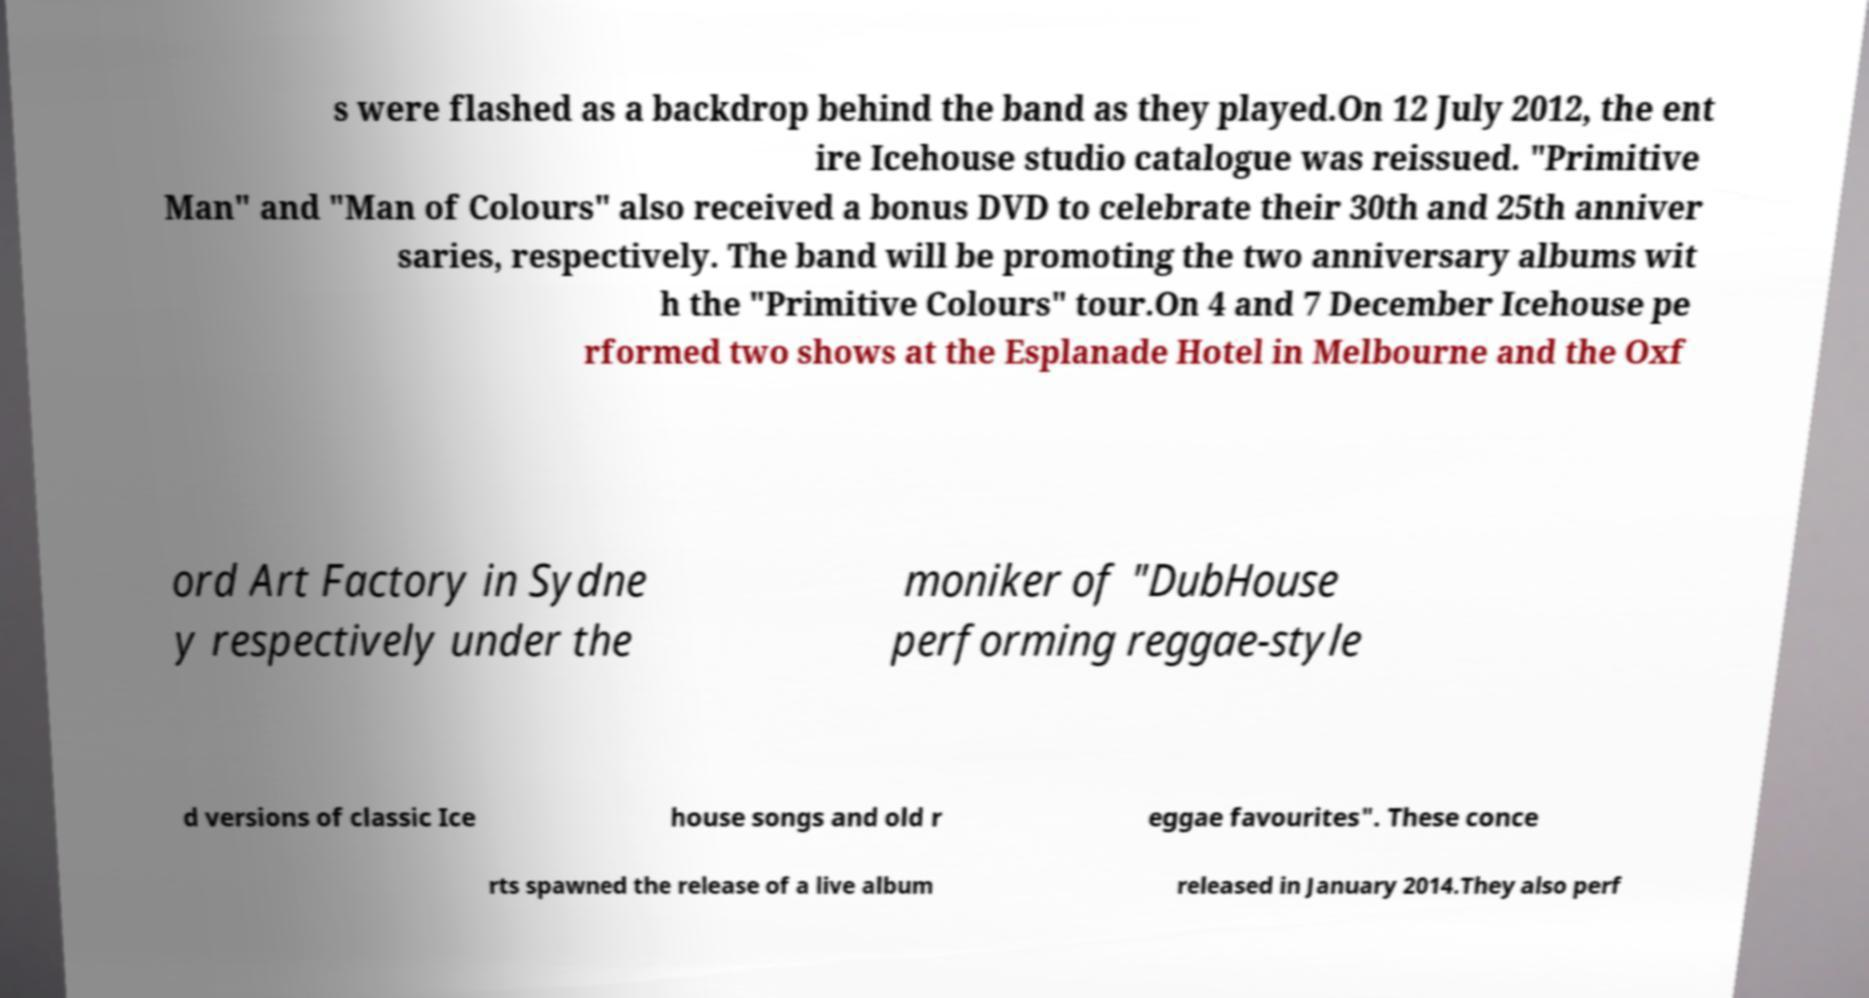What messages or text are displayed in this image? I need them in a readable, typed format. s were flashed as a backdrop behind the band as they played.On 12 July 2012, the ent ire Icehouse studio catalogue was reissued. "Primitive Man" and "Man of Colours" also received a bonus DVD to celebrate their 30th and 25th anniver saries, respectively. The band will be promoting the two anniversary albums wit h the "Primitive Colours" tour.On 4 and 7 December Icehouse pe rformed two shows at the Esplanade Hotel in Melbourne and the Oxf ord Art Factory in Sydne y respectively under the moniker of "DubHouse performing reggae-style d versions of classic Ice house songs and old r eggae favourites". These conce rts spawned the release of a live album released in January 2014.They also perf 